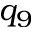Convert formula to latex. <formula><loc_0><loc_0><loc_500><loc_500>q _ { 9 }</formula> 